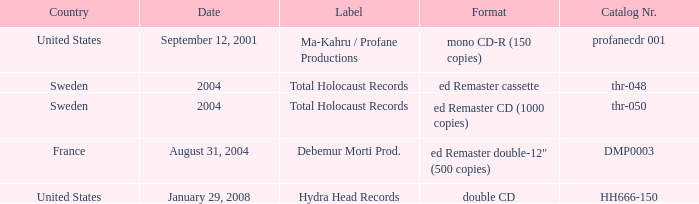In which country is the format ed remaster double-12" (500 copies) available? France. 